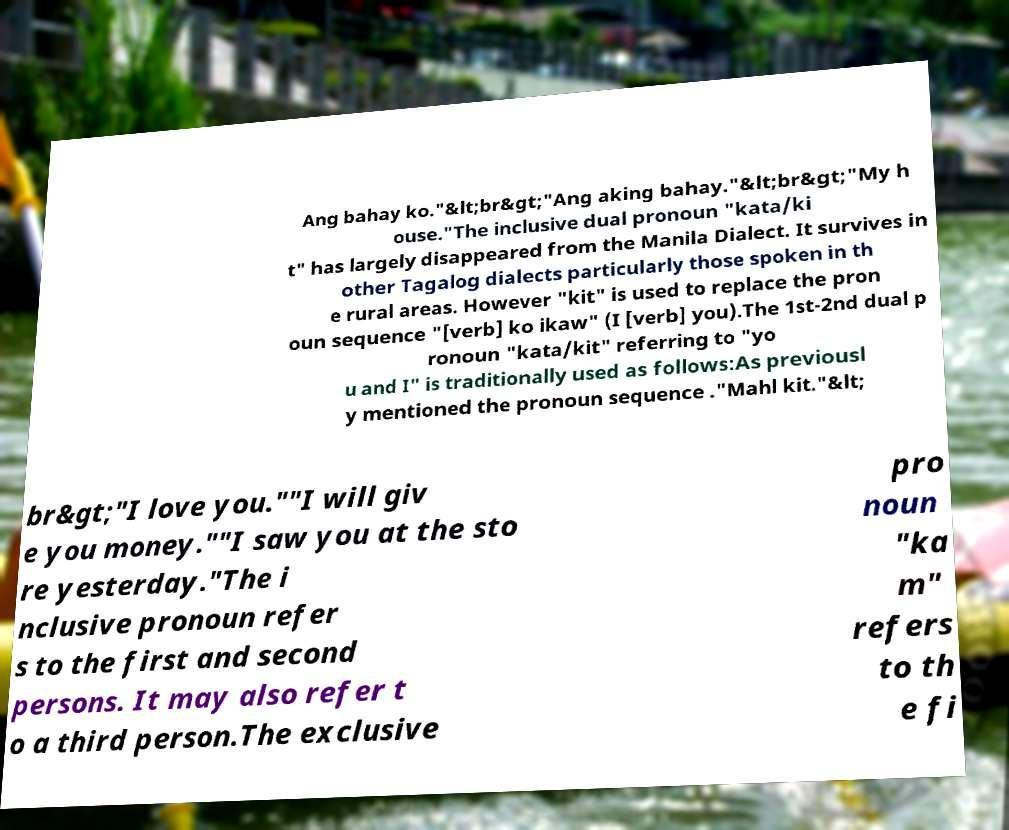What messages or text are displayed in this image? I need them in a readable, typed format. Ang bahay ko."&lt;br&gt;"Ang aking bahay."&lt;br&gt;"My h ouse."The inclusive dual pronoun "kata/ki t" has largely disappeared from the Manila Dialect. It survives in other Tagalog dialects particularly those spoken in th e rural areas. However "kit" is used to replace the pron oun sequence "[verb] ko ikaw" (I [verb] you).The 1st-2nd dual p ronoun "kata/kit" referring to "yo u and I" is traditionally used as follows:As previousl y mentioned the pronoun sequence ."Mahl kit."&lt; br&gt;"I love you.""I will giv e you money.""I saw you at the sto re yesterday."The i nclusive pronoun refer s to the first and second persons. It may also refer t o a third person.The exclusive pro noun "ka m" refers to th e fi 